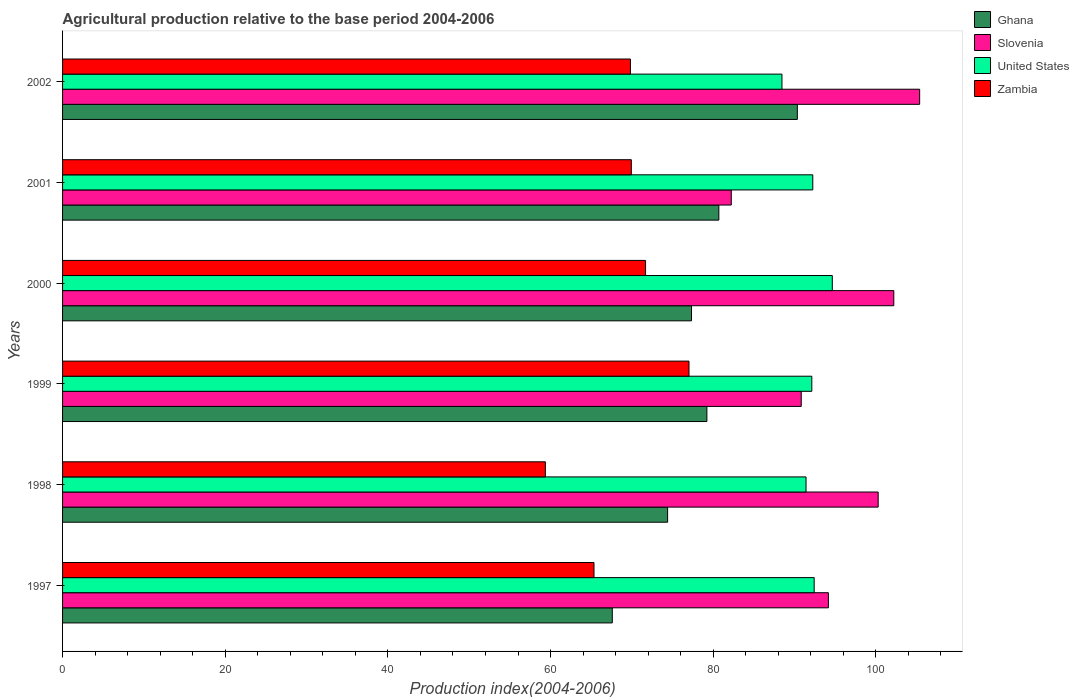How many bars are there on the 3rd tick from the top?
Provide a succinct answer. 4. How many bars are there on the 5th tick from the bottom?
Provide a short and direct response. 4. What is the label of the 2nd group of bars from the top?
Provide a short and direct response. 2001. In how many cases, is the number of bars for a given year not equal to the number of legend labels?
Your response must be concise. 0. What is the agricultural production index in Ghana in 1998?
Your response must be concise. 74.39. Across all years, what is the maximum agricultural production index in Slovenia?
Provide a short and direct response. 105.38. Across all years, what is the minimum agricultural production index in Zambia?
Your response must be concise. 59.36. In which year was the agricultural production index in Ghana maximum?
Your response must be concise. 2002. In which year was the agricultural production index in Zambia minimum?
Provide a short and direct response. 1998. What is the total agricultural production index in Ghana in the graph?
Give a very brief answer. 469.56. What is the difference between the agricultural production index in Zambia in 2000 and that in 2002?
Offer a terse response. 1.86. What is the difference between the agricultural production index in Zambia in 1997 and the agricultural production index in Ghana in 1998?
Keep it short and to the point. -9.05. What is the average agricultural production index in Slovenia per year?
Your answer should be very brief. 95.84. In the year 1999, what is the difference between the agricultural production index in Slovenia and agricultural production index in Zambia?
Give a very brief answer. 13.8. In how many years, is the agricultural production index in Zambia greater than 72 ?
Ensure brevity in your answer.  1. What is the ratio of the agricultural production index in Zambia in 1997 to that in 1998?
Ensure brevity in your answer.  1.1. Is the difference between the agricultural production index in Slovenia in 1997 and 1999 greater than the difference between the agricultural production index in Zambia in 1997 and 1999?
Keep it short and to the point. Yes. What is the difference between the highest and the second highest agricultural production index in United States?
Provide a succinct answer. 2.23. What is the difference between the highest and the lowest agricultural production index in Ghana?
Provide a succinct answer. 22.75. Is it the case that in every year, the sum of the agricultural production index in Ghana and agricultural production index in Slovenia is greater than the sum of agricultural production index in Zambia and agricultural production index in United States?
Offer a terse response. Yes. Is it the case that in every year, the sum of the agricultural production index in Zambia and agricultural production index in Ghana is greater than the agricultural production index in Slovenia?
Provide a short and direct response. Yes. How many bars are there?
Give a very brief answer. 24. Are all the bars in the graph horizontal?
Provide a short and direct response. Yes. Does the graph contain any zero values?
Make the answer very short. No. How many legend labels are there?
Your answer should be compact. 4. How are the legend labels stacked?
Ensure brevity in your answer.  Vertical. What is the title of the graph?
Ensure brevity in your answer.  Agricultural production relative to the base period 2004-2006. What is the label or title of the X-axis?
Offer a very short reply. Production index(2004-2006). What is the label or title of the Y-axis?
Provide a short and direct response. Years. What is the Production index(2004-2006) in Ghana in 1997?
Provide a short and direct response. 67.59. What is the Production index(2004-2006) of Slovenia in 1997?
Keep it short and to the point. 94.16. What is the Production index(2004-2006) of United States in 1997?
Keep it short and to the point. 92.41. What is the Production index(2004-2006) in Zambia in 1997?
Ensure brevity in your answer.  65.34. What is the Production index(2004-2006) of Ghana in 1998?
Ensure brevity in your answer.  74.39. What is the Production index(2004-2006) in Slovenia in 1998?
Offer a very short reply. 100.28. What is the Production index(2004-2006) in United States in 1998?
Keep it short and to the point. 91.41. What is the Production index(2004-2006) of Zambia in 1998?
Provide a short and direct response. 59.36. What is the Production index(2004-2006) of Ghana in 1999?
Ensure brevity in your answer.  79.22. What is the Production index(2004-2006) of Slovenia in 1999?
Make the answer very short. 90.82. What is the Production index(2004-2006) of United States in 1999?
Provide a short and direct response. 92.12. What is the Production index(2004-2006) of Zambia in 1999?
Your answer should be compact. 77.02. What is the Production index(2004-2006) of Ghana in 2000?
Offer a very short reply. 77.33. What is the Production index(2004-2006) of Slovenia in 2000?
Ensure brevity in your answer.  102.2. What is the Production index(2004-2006) of United States in 2000?
Keep it short and to the point. 94.64. What is the Production index(2004-2006) of Zambia in 2000?
Your response must be concise. 71.68. What is the Production index(2004-2006) in Ghana in 2001?
Ensure brevity in your answer.  80.69. What is the Production index(2004-2006) of Slovenia in 2001?
Offer a very short reply. 82.22. What is the Production index(2004-2006) of United States in 2001?
Your answer should be very brief. 92.24. What is the Production index(2004-2006) of Zambia in 2001?
Your answer should be compact. 69.93. What is the Production index(2004-2006) of Ghana in 2002?
Provide a short and direct response. 90.34. What is the Production index(2004-2006) of Slovenia in 2002?
Offer a very short reply. 105.38. What is the Production index(2004-2006) in United States in 2002?
Your answer should be very brief. 88.45. What is the Production index(2004-2006) in Zambia in 2002?
Give a very brief answer. 69.82. Across all years, what is the maximum Production index(2004-2006) of Ghana?
Offer a very short reply. 90.34. Across all years, what is the maximum Production index(2004-2006) in Slovenia?
Make the answer very short. 105.38. Across all years, what is the maximum Production index(2004-2006) in United States?
Your response must be concise. 94.64. Across all years, what is the maximum Production index(2004-2006) of Zambia?
Provide a succinct answer. 77.02. Across all years, what is the minimum Production index(2004-2006) in Ghana?
Give a very brief answer. 67.59. Across all years, what is the minimum Production index(2004-2006) in Slovenia?
Give a very brief answer. 82.22. Across all years, what is the minimum Production index(2004-2006) in United States?
Give a very brief answer. 88.45. Across all years, what is the minimum Production index(2004-2006) in Zambia?
Your response must be concise. 59.36. What is the total Production index(2004-2006) in Ghana in the graph?
Your answer should be compact. 469.56. What is the total Production index(2004-2006) of Slovenia in the graph?
Your answer should be very brief. 575.06. What is the total Production index(2004-2006) in United States in the graph?
Provide a short and direct response. 551.27. What is the total Production index(2004-2006) of Zambia in the graph?
Ensure brevity in your answer.  413.15. What is the difference between the Production index(2004-2006) of Ghana in 1997 and that in 1998?
Offer a very short reply. -6.8. What is the difference between the Production index(2004-2006) in Slovenia in 1997 and that in 1998?
Keep it short and to the point. -6.12. What is the difference between the Production index(2004-2006) of United States in 1997 and that in 1998?
Provide a short and direct response. 1. What is the difference between the Production index(2004-2006) of Zambia in 1997 and that in 1998?
Your answer should be compact. 5.98. What is the difference between the Production index(2004-2006) of Ghana in 1997 and that in 1999?
Keep it short and to the point. -11.63. What is the difference between the Production index(2004-2006) in Slovenia in 1997 and that in 1999?
Offer a terse response. 3.34. What is the difference between the Production index(2004-2006) in United States in 1997 and that in 1999?
Offer a very short reply. 0.29. What is the difference between the Production index(2004-2006) in Zambia in 1997 and that in 1999?
Give a very brief answer. -11.68. What is the difference between the Production index(2004-2006) in Ghana in 1997 and that in 2000?
Ensure brevity in your answer.  -9.74. What is the difference between the Production index(2004-2006) of Slovenia in 1997 and that in 2000?
Offer a terse response. -8.04. What is the difference between the Production index(2004-2006) of United States in 1997 and that in 2000?
Provide a succinct answer. -2.23. What is the difference between the Production index(2004-2006) in Zambia in 1997 and that in 2000?
Offer a very short reply. -6.34. What is the difference between the Production index(2004-2006) in Slovenia in 1997 and that in 2001?
Give a very brief answer. 11.94. What is the difference between the Production index(2004-2006) in United States in 1997 and that in 2001?
Offer a very short reply. 0.17. What is the difference between the Production index(2004-2006) in Zambia in 1997 and that in 2001?
Your answer should be compact. -4.59. What is the difference between the Production index(2004-2006) in Ghana in 1997 and that in 2002?
Provide a succinct answer. -22.75. What is the difference between the Production index(2004-2006) of Slovenia in 1997 and that in 2002?
Make the answer very short. -11.22. What is the difference between the Production index(2004-2006) of United States in 1997 and that in 2002?
Make the answer very short. 3.96. What is the difference between the Production index(2004-2006) of Zambia in 1997 and that in 2002?
Keep it short and to the point. -4.48. What is the difference between the Production index(2004-2006) in Ghana in 1998 and that in 1999?
Make the answer very short. -4.83. What is the difference between the Production index(2004-2006) in Slovenia in 1998 and that in 1999?
Keep it short and to the point. 9.46. What is the difference between the Production index(2004-2006) in United States in 1998 and that in 1999?
Give a very brief answer. -0.71. What is the difference between the Production index(2004-2006) in Zambia in 1998 and that in 1999?
Your response must be concise. -17.66. What is the difference between the Production index(2004-2006) in Ghana in 1998 and that in 2000?
Make the answer very short. -2.94. What is the difference between the Production index(2004-2006) in Slovenia in 1998 and that in 2000?
Provide a succinct answer. -1.92. What is the difference between the Production index(2004-2006) of United States in 1998 and that in 2000?
Your response must be concise. -3.23. What is the difference between the Production index(2004-2006) of Zambia in 1998 and that in 2000?
Keep it short and to the point. -12.32. What is the difference between the Production index(2004-2006) in Slovenia in 1998 and that in 2001?
Your answer should be very brief. 18.06. What is the difference between the Production index(2004-2006) in United States in 1998 and that in 2001?
Provide a short and direct response. -0.83. What is the difference between the Production index(2004-2006) of Zambia in 1998 and that in 2001?
Provide a short and direct response. -10.57. What is the difference between the Production index(2004-2006) of Ghana in 1998 and that in 2002?
Give a very brief answer. -15.95. What is the difference between the Production index(2004-2006) of Slovenia in 1998 and that in 2002?
Offer a very short reply. -5.1. What is the difference between the Production index(2004-2006) of United States in 1998 and that in 2002?
Ensure brevity in your answer.  2.96. What is the difference between the Production index(2004-2006) of Zambia in 1998 and that in 2002?
Offer a very short reply. -10.46. What is the difference between the Production index(2004-2006) in Ghana in 1999 and that in 2000?
Your response must be concise. 1.89. What is the difference between the Production index(2004-2006) of Slovenia in 1999 and that in 2000?
Keep it short and to the point. -11.38. What is the difference between the Production index(2004-2006) in United States in 1999 and that in 2000?
Your answer should be very brief. -2.52. What is the difference between the Production index(2004-2006) of Zambia in 1999 and that in 2000?
Offer a terse response. 5.34. What is the difference between the Production index(2004-2006) in Ghana in 1999 and that in 2001?
Your response must be concise. -1.47. What is the difference between the Production index(2004-2006) in United States in 1999 and that in 2001?
Give a very brief answer. -0.12. What is the difference between the Production index(2004-2006) of Zambia in 1999 and that in 2001?
Give a very brief answer. 7.09. What is the difference between the Production index(2004-2006) in Ghana in 1999 and that in 2002?
Keep it short and to the point. -11.12. What is the difference between the Production index(2004-2006) in Slovenia in 1999 and that in 2002?
Offer a very short reply. -14.56. What is the difference between the Production index(2004-2006) in United States in 1999 and that in 2002?
Provide a short and direct response. 3.67. What is the difference between the Production index(2004-2006) of Ghana in 2000 and that in 2001?
Provide a succinct answer. -3.36. What is the difference between the Production index(2004-2006) in Slovenia in 2000 and that in 2001?
Provide a succinct answer. 19.98. What is the difference between the Production index(2004-2006) of United States in 2000 and that in 2001?
Your response must be concise. 2.4. What is the difference between the Production index(2004-2006) of Zambia in 2000 and that in 2001?
Offer a terse response. 1.75. What is the difference between the Production index(2004-2006) in Ghana in 2000 and that in 2002?
Your answer should be compact. -13.01. What is the difference between the Production index(2004-2006) in Slovenia in 2000 and that in 2002?
Your answer should be compact. -3.18. What is the difference between the Production index(2004-2006) of United States in 2000 and that in 2002?
Give a very brief answer. 6.19. What is the difference between the Production index(2004-2006) of Zambia in 2000 and that in 2002?
Provide a short and direct response. 1.86. What is the difference between the Production index(2004-2006) of Ghana in 2001 and that in 2002?
Ensure brevity in your answer.  -9.65. What is the difference between the Production index(2004-2006) in Slovenia in 2001 and that in 2002?
Your response must be concise. -23.16. What is the difference between the Production index(2004-2006) of United States in 2001 and that in 2002?
Your answer should be very brief. 3.79. What is the difference between the Production index(2004-2006) in Zambia in 2001 and that in 2002?
Provide a succinct answer. 0.11. What is the difference between the Production index(2004-2006) in Ghana in 1997 and the Production index(2004-2006) in Slovenia in 1998?
Your response must be concise. -32.69. What is the difference between the Production index(2004-2006) in Ghana in 1997 and the Production index(2004-2006) in United States in 1998?
Ensure brevity in your answer.  -23.82. What is the difference between the Production index(2004-2006) of Ghana in 1997 and the Production index(2004-2006) of Zambia in 1998?
Offer a very short reply. 8.23. What is the difference between the Production index(2004-2006) in Slovenia in 1997 and the Production index(2004-2006) in United States in 1998?
Your answer should be very brief. 2.75. What is the difference between the Production index(2004-2006) of Slovenia in 1997 and the Production index(2004-2006) of Zambia in 1998?
Keep it short and to the point. 34.8. What is the difference between the Production index(2004-2006) of United States in 1997 and the Production index(2004-2006) of Zambia in 1998?
Provide a short and direct response. 33.05. What is the difference between the Production index(2004-2006) of Ghana in 1997 and the Production index(2004-2006) of Slovenia in 1999?
Provide a short and direct response. -23.23. What is the difference between the Production index(2004-2006) in Ghana in 1997 and the Production index(2004-2006) in United States in 1999?
Keep it short and to the point. -24.53. What is the difference between the Production index(2004-2006) in Ghana in 1997 and the Production index(2004-2006) in Zambia in 1999?
Your answer should be very brief. -9.43. What is the difference between the Production index(2004-2006) of Slovenia in 1997 and the Production index(2004-2006) of United States in 1999?
Your response must be concise. 2.04. What is the difference between the Production index(2004-2006) in Slovenia in 1997 and the Production index(2004-2006) in Zambia in 1999?
Make the answer very short. 17.14. What is the difference between the Production index(2004-2006) in United States in 1997 and the Production index(2004-2006) in Zambia in 1999?
Make the answer very short. 15.39. What is the difference between the Production index(2004-2006) of Ghana in 1997 and the Production index(2004-2006) of Slovenia in 2000?
Your response must be concise. -34.61. What is the difference between the Production index(2004-2006) in Ghana in 1997 and the Production index(2004-2006) in United States in 2000?
Keep it short and to the point. -27.05. What is the difference between the Production index(2004-2006) of Ghana in 1997 and the Production index(2004-2006) of Zambia in 2000?
Provide a short and direct response. -4.09. What is the difference between the Production index(2004-2006) of Slovenia in 1997 and the Production index(2004-2006) of United States in 2000?
Offer a terse response. -0.48. What is the difference between the Production index(2004-2006) of Slovenia in 1997 and the Production index(2004-2006) of Zambia in 2000?
Make the answer very short. 22.48. What is the difference between the Production index(2004-2006) of United States in 1997 and the Production index(2004-2006) of Zambia in 2000?
Give a very brief answer. 20.73. What is the difference between the Production index(2004-2006) of Ghana in 1997 and the Production index(2004-2006) of Slovenia in 2001?
Your response must be concise. -14.63. What is the difference between the Production index(2004-2006) of Ghana in 1997 and the Production index(2004-2006) of United States in 2001?
Ensure brevity in your answer.  -24.65. What is the difference between the Production index(2004-2006) of Ghana in 1997 and the Production index(2004-2006) of Zambia in 2001?
Offer a terse response. -2.34. What is the difference between the Production index(2004-2006) of Slovenia in 1997 and the Production index(2004-2006) of United States in 2001?
Offer a terse response. 1.92. What is the difference between the Production index(2004-2006) of Slovenia in 1997 and the Production index(2004-2006) of Zambia in 2001?
Offer a terse response. 24.23. What is the difference between the Production index(2004-2006) of United States in 1997 and the Production index(2004-2006) of Zambia in 2001?
Ensure brevity in your answer.  22.48. What is the difference between the Production index(2004-2006) of Ghana in 1997 and the Production index(2004-2006) of Slovenia in 2002?
Your response must be concise. -37.79. What is the difference between the Production index(2004-2006) in Ghana in 1997 and the Production index(2004-2006) in United States in 2002?
Your response must be concise. -20.86. What is the difference between the Production index(2004-2006) in Ghana in 1997 and the Production index(2004-2006) in Zambia in 2002?
Give a very brief answer. -2.23. What is the difference between the Production index(2004-2006) in Slovenia in 1997 and the Production index(2004-2006) in United States in 2002?
Keep it short and to the point. 5.71. What is the difference between the Production index(2004-2006) of Slovenia in 1997 and the Production index(2004-2006) of Zambia in 2002?
Provide a short and direct response. 24.34. What is the difference between the Production index(2004-2006) in United States in 1997 and the Production index(2004-2006) in Zambia in 2002?
Make the answer very short. 22.59. What is the difference between the Production index(2004-2006) of Ghana in 1998 and the Production index(2004-2006) of Slovenia in 1999?
Offer a terse response. -16.43. What is the difference between the Production index(2004-2006) of Ghana in 1998 and the Production index(2004-2006) of United States in 1999?
Offer a terse response. -17.73. What is the difference between the Production index(2004-2006) in Ghana in 1998 and the Production index(2004-2006) in Zambia in 1999?
Give a very brief answer. -2.63. What is the difference between the Production index(2004-2006) of Slovenia in 1998 and the Production index(2004-2006) of United States in 1999?
Ensure brevity in your answer.  8.16. What is the difference between the Production index(2004-2006) in Slovenia in 1998 and the Production index(2004-2006) in Zambia in 1999?
Your response must be concise. 23.26. What is the difference between the Production index(2004-2006) of United States in 1998 and the Production index(2004-2006) of Zambia in 1999?
Your answer should be compact. 14.39. What is the difference between the Production index(2004-2006) of Ghana in 1998 and the Production index(2004-2006) of Slovenia in 2000?
Offer a terse response. -27.81. What is the difference between the Production index(2004-2006) in Ghana in 1998 and the Production index(2004-2006) in United States in 2000?
Give a very brief answer. -20.25. What is the difference between the Production index(2004-2006) of Ghana in 1998 and the Production index(2004-2006) of Zambia in 2000?
Offer a very short reply. 2.71. What is the difference between the Production index(2004-2006) in Slovenia in 1998 and the Production index(2004-2006) in United States in 2000?
Your response must be concise. 5.64. What is the difference between the Production index(2004-2006) in Slovenia in 1998 and the Production index(2004-2006) in Zambia in 2000?
Provide a short and direct response. 28.6. What is the difference between the Production index(2004-2006) of United States in 1998 and the Production index(2004-2006) of Zambia in 2000?
Keep it short and to the point. 19.73. What is the difference between the Production index(2004-2006) of Ghana in 1998 and the Production index(2004-2006) of Slovenia in 2001?
Provide a short and direct response. -7.83. What is the difference between the Production index(2004-2006) of Ghana in 1998 and the Production index(2004-2006) of United States in 2001?
Your answer should be compact. -17.85. What is the difference between the Production index(2004-2006) of Ghana in 1998 and the Production index(2004-2006) of Zambia in 2001?
Keep it short and to the point. 4.46. What is the difference between the Production index(2004-2006) in Slovenia in 1998 and the Production index(2004-2006) in United States in 2001?
Keep it short and to the point. 8.04. What is the difference between the Production index(2004-2006) in Slovenia in 1998 and the Production index(2004-2006) in Zambia in 2001?
Give a very brief answer. 30.35. What is the difference between the Production index(2004-2006) in United States in 1998 and the Production index(2004-2006) in Zambia in 2001?
Offer a terse response. 21.48. What is the difference between the Production index(2004-2006) in Ghana in 1998 and the Production index(2004-2006) in Slovenia in 2002?
Offer a very short reply. -30.99. What is the difference between the Production index(2004-2006) of Ghana in 1998 and the Production index(2004-2006) of United States in 2002?
Make the answer very short. -14.06. What is the difference between the Production index(2004-2006) in Ghana in 1998 and the Production index(2004-2006) in Zambia in 2002?
Keep it short and to the point. 4.57. What is the difference between the Production index(2004-2006) in Slovenia in 1998 and the Production index(2004-2006) in United States in 2002?
Keep it short and to the point. 11.83. What is the difference between the Production index(2004-2006) of Slovenia in 1998 and the Production index(2004-2006) of Zambia in 2002?
Give a very brief answer. 30.46. What is the difference between the Production index(2004-2006) in United States in 1998 and the Production index(2004-2006) in Zambia in 2002?
Provide a short and direct response. 21.59. What is the difference between the Production index(2004-2006) of Ghana in 1999 and the Production index(2004-2006) of Slovenia in 2000?
Offer a terse response. -22.98. What is the difference between the Production index(2004-2006) of Ghana in 1999 and the Production index(2004-2006) of United States in 2000?
Offer a very short reply. -15.42. What is the difference between the Production index(2004-2006) of Ghana in 1999 and the Production index(2004-2006) of Zambia in 2000?
Provide a short and direct response. 7.54. What is the difference between the Production index(2004-2006) in Slovenia in 1999 and the Production index(2004-2006) in United States in 2000?
Provide a short and direct response. -3.82. What is the difference between the Production index(2004-2006) in Slovenia in 1999 and the Production index(2004-2006) in Zambia in 2000?
Keep it short and to the point. 19.14. What is the difference between the Production index(2004-2006) in United States in 1999 and the Production index(2004-2006) in Zambia in 2000?
Keep it short and to the point. 20.44. What is the difference between the Production index(2004-2006) in Ghana in 1999 and the Production index(2004-2006) in United States in 2001?
Your response must be concise. -13.02. What is the difference between the Production index(2004-2006) of Ghana in 1999 and the Production index(2004-2006) of Zambia in 2001?
Give a very brief answer. 9.29. What is the difference between the Production index(2004-2006) of Slovenia in 1999 and the Production index(2004-2006) of United States in 2001?
Provide a short and direct response. -1.42. What is the difference between the Production index(2004-2006) in Slovenia in 1999 and the Production index(2004-2006) in Zambia in 2001?
Offer a terse response. 20.89. What is the difference between the Production index(2004-2006) in United States in 1999 and the Production index(2004-2006) in Zambia in 2001?
Keep it short and to the point. 22.19. What is the difference between the Production index(2004-2006) in Ghana in 1999 and the Production index(2004-2006) in Slovenia in 2002?
Your answer should be very brief. -26.16. What is the difference between the Production index(2004-2006) of Ghana in 1999 and the Production index(2004-2006) of United States in 2002?
Give a very brief answer. -9.23. What is the difference between the Production index(2004-2006) in Ghana in 1999 and the Production index(2004-2006) in Zambia in 2002?
Your answer should be compact. 9.4. What is the difference between the Production index(2004-2006) in Slovenia in 1999 and the Production index(2004-2006) in United States in 2002?
Your response must be concise. 2.37. What is the difference between the Production index(2004-2006) of Slovenia in 1999 and the Production index(2004-2006) of Zambia in 2002?
Your answer should be very brief. 21. What is the difference between the Production index(2004-2006) of United States in 1999 and the Production index(2004-2006) of Zambia in 2002?
Keep it short and to the point. 22.3. What is the difference between the Production index(2004-2006) of Ghana in 2000 and the Production index(2004-2006) of Slovenia in 2001?
Your answer should be compact. -4.89. What is the difference between the Production index(2004-2006) in Ghana in 2000 and the Production index(2004-2006) in United States in 2001?
Offer a terse response. -14.91. What is the difference between the Production index(2004-2006) of Ghana in 2000 and the Production index(2004-2006) of Zambia in 2001?
Make the answer very short. 7.4. What is the difference between the Production index(2004-2006) of Slovenia in 2000 and the Production index(2004-2006) of United States in 2001?
Your answer should be compact. 9.96. What is the difference between the Production index(2004-2006) of Slovenia in 2000 and the Production index(2004-2006) of Zambia in 2001?
Ensure brevity in your answer.  32.27. What is the difference between the Production index(2004-2006) of United States in 2000 and the Production index(2004-2006) of Zambia in 2001?
Provide a short and direct response. 24.71. What is the difference between the Production index(2004-2006) in Ghana in 2000 and the Production index(2004-2006) in Slovenia in 2002?
Keep it short and to the point. -28.05. What is the difference between the Production index(2004-2006) of Ghana in 2000 and the Production index(2004-2006) of United States in 2002?
Provide a short and direct response. -11.12. What is the difference between the Production index(2004-2006) of Ghana in 2000 and the Production index(2004-2006) of Zambia in 2002?
Ensure brevity in your answer.  7.51. What is the difference between the Production index(2004-2006) of Slovenia in 2000 and the Production index(2004-2006) of United States in 2002?
Offer a very short reply. 13.75. What is the difference between the Production index(2004-2006) of Slovenia in 2000 and the Production index(2004-2006) of Zambia in 2002?
Your response must be concise. 32.38. What is the difference between the Production index(2004-2006) in United States in 2000 and the Production index(2004-2006) in Zambia in 2002?
Your answer should be compact. 24.82. What is the difference between the Production index(2004-2006) in Ghana in 2001 and the Production index(2004-2006) in Slovenia in 2002?
Keep it short and to the point. -24.69. What is the difference between the Production index(2004-2006) of Ghana in 2001 and the Production index(2004-2006) of United States in 2002?
Offer a terse response. -7.76. What is the difference between the Production index(2004-2006) in Ghana in 2001 and the Production index(2004-2006) in Zambia in 2002?
Your answer should be very brief. 10.87. What is the difference between the Production index(2004-2006) in Slovenia in 2001 and the Production index(2004-2006) in United States in 2002?
Offer a terse response. -6.23. What is the difference between the Production index(2004-2006) in United States in 2001 and the Production index(2004-2006) in Zambia in 2002?
Give a very brief answer. 22.42. What is the average Production index(2004-2006) of Ghana per year?
Make the answer very short. 78.26. What is the average Production index(2004-2006) of Slovenia per year?
Your answer should be very brief. 95.84. What is the average Production index(2004-2006) of United States per year?
Ensure brevity in your answer.  91.88. What is the average Production index(2004-2006) in Zambia per year?
Make the answer very short. 68.86. In the year 1997, what is the difference between the Production index(2004-2006) in Ghana and Production index(2004-2006) in Slovenia?
Your answer should be very brief. -26.57. In the year 1997, what is the difference between the Production index(2004-2006) in Ghana and Production index(2004-2006) in United States?
Your answer should be very brief. -24.82. In the year 1997, what is the difference between the Production index(2004-2006) of Ghana and Production index(2004-2006) of Zambia?
Your answer should be very brief. 2.25. In the year 1997, what is the difference between the Production index(2004-2006) of Slovenia and Production index(2004-2006) of United States?
Offer a very short reply. 1.75. In the year 1997, what is the difference between the Production index(2004-2006) in Slovenia and Production index(2004-2006) in Zambia?
Provide a short and direct response. 28.82. In the year 1997, what is the difference between the Production index(2004-2006) in United States and Production index(2004-2006) in Zambia?
Ensure brevity in your answer.  27.07. In the year 1998, what is the difference between the Production index(2004-2006) of Ghana and Production index(2004-2006) of Slovenia?
Keep it short and to the point. -25.89. In the year 1998, what is the difference between the Production index(2004-2006) of Ghana and Production index(2004-2006) of United States?
Provide a short and direct response. -17.02. In the year 1998, what is the difference between the Production index(2004-2006) in Ghana and Production index(2004-2006) in Zambia?
Give a very brief answer. 15.03. In the year 1998, what is the difference between the Production index(2004-2006) of Slovenia and Production index(2004-2006) of United States?
Provide a short and direct response. 8.87. In the year 1998, what is the difference between the Production index(2004-2006) in Slovenia and Production index(2004-2006) in Zambia?
Your answer should be compact. 40.92. In the year 1998, what is the difference between the Production index(2004-2006) of United States and Production index(2004-2006) of Zambia?
Offer a very short reply. 32.05. In the year 1999, what is the difference between the Production index(2004-2006) of Ghana and Production index(2004-2006) of Slovenia?
Your response must be concise. -11.6. In the year 1999, what is the difference between the Production index(2004-2006) of Ghana and Production index(2004-2006) of United States?
Provide a short and direct response. -12.9. In the year 1999, what is the difference between the Production index(2004-2006) of Ghana and Production index(2004-2006) of Zambia?
Keep it short and to the point. 2.2. In the year 1999, what is the difference between the Production index(2004-2006) in Slovenia and Production index(2004-2006) in United States?
Keep it short and to the point. -1.3. In the year 2000, what is the difference between the Production index(2004-2006) of Ghana and Production index(2004-2006) of Slovenia?
Your answer should be compact. -24.87. In the year 2000, what is the difference between the Production index(2004-2006) of Ghana and Production index(2004-2006) of United States?
Offer a very short reply. -17.31. In the year 2000, what is the difference between the Production index(2004-2006) in Ghana and Production index(2004-2006) in Zambia?
Your answer should be compact. 5.65. In the year 2000, what is the difference between the Production index(2004-2006) in Slovenia and Production index(2004-2006) in United States?
Make the answer very short. 7.56. In the year 2000, what is the difference between the Production index(2004-2006) in Slovenia and Production index(2004-2006) in Zambia?
Keep it short and to the point. 30.52. In the year 2000, what is the difference between the Production index(2004-2006) in United States and Production index(2004-2006) in Zambia?
Keep it short and to the point. 22.96. In the year 2001, what is the difference between the Production index(2004-2006) of Ghana and Production index(2004-2006) of Slovenia?
Your response must be concise. -1.53. In the year 2001, what is the difference between the Production index(2004-2006) of Ghana and Production index(2004-2006) of United States?
Provide a succinct answer. -11.55. In the year 2001, what is the difference between the Production index(2004-2006) in Ghana and Production index(2004-2006) in Zambia?
Make the answer very short. 10.76. In the year 2001, what is the difference between the Production index(2004-2006) of Slovenia and Production index(2004-2006) of United States?
Your response must be concise. -10.02. In the year 2001, what is the difference between the Production index(2004-2006) in Slovenia and Production index(2004-2006) in Zambia?
Provide a succinct answer. 12.29. In the year 2001, what is the difference between the Production index(2004-2006) in United States and Production index(2004-2006) in Zambia?
Keep it short and to the point. 22.31. In the year 2002, what is the difference between the Production index(2004-2006) in Ghana and Production index(2004-2006) in Slovenia?
Offer a very short reply. -15.04. In the year 2002, what is the difference between the Production index(2004-2006) in Ghana and Production index(2004-2006) in United States?
Provide a succinct answer. 1.89. In the year 2002, what is the difference between the Production index(2004-2006) in Ghana and Production index(2004-2006) in Zambia?
Provide a succinct answer. 20.52. In the year 2002, what is the difference between the Production index(2004-2006) in Slovenia and Production index(2004-2006) in United States?
Make the answer very short. 16.93. In the year 2002, what is the difference between the Production index(2004-2006) in Slovenia and Production index(2004-2006) in Zambia?
Provide a succinct answer. 35.56. In the year 2002, what is the difference between the Production index(2004-2006) of United States and Production index(2004-2006) of Zambia?
Keep it short and to the point. 18.63. What is the ratio of the Production index(2004-2006) of Ghana in 1997 to that in 1998?
Offer a terse response. 0.91. What is the ratio of the Production index(2004-2006) in Slovenia in 1997 to that in 1998?
Ensure brevity in your answer.  0.94. What is the ratio of the Production index(2004-2006) in United States in 1997 to that in 1998?
Provide a short and direct response. 1.01. What is the ratio of the Production index(2004-2006) in Zambia in 1997 to that in 1998?
Provide a short and direct response. 1.1. What is the ratio of the Production index(2004-2006) in Ghana in 1997 to that in 1999?
Provide a succinct answer. 0.85. What is the ratio of the Production index(2004-2006) in Slovenia in 1997 to that in 1999?
Your response must be concise. 1.04. What is the ratio of the Production index(2004-2006) in Zambia in 1997 to that in 1999?
Offer a terse response. 0.85. What is the ratio of the Production index(2004-2006) in Ghana in 1997 to that in 2000?
Ensure brevity in your answer.  0.87. What is the ratio of the Production index(2004-2006) of Slovenia in 1997 to that in 2000?
Your answer should be compact. 0.92. What is the ratio of the Production index(2004-2006) in United States in 1997 to that in 2000?
Offer a very short reply. 0.98. What is the ratio of the Production index(2004-2006) in Zambia in 1997 to that in 2000?
Offer a terse response. 0.91. What is the ratio of the Production index(2004-2006) of Ghana in 1997 to that in 2001?
Offer a terse response. 0.84. What is the ratio of the Production index(2004-2006) in Slovenia in 1997 to that in 2001?
Ensure brevity in your answer.  1.15. What is the ratio of the Production index(2004-2006) of Zambia in 1997 to that in 2001?
Offer a terse response. 0.93. What is the ratio of the Production index(2004-2006) of Ghana in 1997 to that in 2002?
Keep it short and to the point. 0.75. What is the ratio of the Production index(2004-2006) in Slovenia in 1997 to that in 2002?
Offer a terse response. 0.89. What is the ratio of the Production index(2004-2006) in United States in 1997 to that in 2002?
Provide a succinct answer. 1.04. What is the ratio of the Production index(2004-2006) in Zambia in 1997 to that in 2002?
Give a very brief answer. 0.94. What is the ratio of the Production index(2004-2006) of Ghana in 1998 to that in 1999?
Ensure brevity in your answer.  0.94. What is the ratio of the Production index(2004-2006) of Slovenia in 1998 to that in 1999?
Give a very brief answer. 1.1. What is the ratio of the Production index(2004-2006) of United States in 1998 to that in 1999?
Your answer should be very brief. 0.99. What is the ratio of the Production index(2004-2006) of Zambia in 1998 to that in 1999?
Make the answer very short. 0.77. What is the ratio of the Production index(2004-2006) in Ghana in 1998 to that in 2000?
Your response must be concise. 0.96. What is the ratio of the Production index(2004-2006) of Slovenia in 1998 to that in 2000?
Provide a short and direct response. 0.98. What is the ratio of the Production index(2004-2006) in United States in 1998 to that in 2000?
Your response must be concise. 0.97. What is the ratio of the Production index(2004-2006) of Zambia in 1998 to that in 2000?
Make the answer very short. 0.83. What is the ratio of the Production index(2004-2006) of Ghana in 1998 to that in 2001?
Offer a very short reply. 0.92. What is the ratio of the Production index(2004-2006) in Slovenia in 1998 to that in 2001?
Make the answer very short. 1.22. What is the ratio of the Production index(2004-2006) of United States in 1998 to that in 2001?
Provide a succinct answer. 0.99. What is the ratio of the Production index(2004-2006) of Zambia in 1998 to that in 2001?
Offer a very short reply. 0.85. What is the ratio of the Production index(2004-2006) in Ghana in 1998 to that in 2002?
Provide a succinct answer. 0.82. What is the ratio of the Production index(2004-2006) of Slovenia in 1998 to that in 2002?
Ensure brevity in your answer.  0.95. What is the ratio of the Production index(2004-2006) of United States in 1998 to that in 2002?
Your response must be concise. 1.03. What is the ratio of the Production index(2004-2006) of Zambia in 1998 to that in 2002?
Offer a terse response. 0.85. What is the ratio of the Production index(2004-2006) in Ghana in 1999 to that in 2000?
Make the answer very short. 1.02. What is the ratio of the Production index(2004-2006) in Slovenia in 1999 to that in 2000?
Your response must be concise. 0.89. What is the ratio of the Production index(2004-2006) in United States in 1999 to that in 2000?
Provide a succinct answer. 0.97. What is the ratio of the Production index(2004-2006) in Zambia in 1999 to that in 2000?
Keep it short and to the point. 1.07. What is the ratio of the Production index(2004-2006) in Ghana in 1999 to that in 2001?
Your answer should be very brief. 0.98. What is the ratio of the Production index(2004-2006) in Slovenia in 1999 to that in 2001?
Keep it short and to the point. 1.1. What is the ratio of the Production index(2004-2006) in United States in 1999 to that in 2001?
Ensure brevity in your answer.  1. What is the ratio of the Production index(2004-2006) of Zambia in 1999 to that in 2001?
Your response must be concise. 1.1. What is the ratio of the Production index(2004-2006) of Ghana in 1999 to that in 2002?
Give a very brief answer. 0.88. What is the ratio of the Production index(2004-2006) of Slovenia in 1999 to that in 2002?
Give a very brief answer. 0.86. What is the ratio of the Production index(2004-2006) in United States in 1999 to that in 2002?
Your answer should be compact. 1.04. What is the ratio of the Production index(2004-2006) in Zambia in 1999 to that in 2002?
Your response must be concise. 1.1. What is the ratio of the Production index(2004-2006) in Ghana in 2000 to that in 2001?
Give a very brief answer. 0.96. What is the ratio of the Production index(2004-2006) in Slovenia in 2000 to that in 2001?
Ensure brevity in your answer.  1.24. What is the ratio of the Production index(2004-2006) in United States in 2000 to that in 2001?
Your answer should be very brief. 1.03. What is the ratio of the Production index(2004-2006) in Ghana in 2000 to that in 2002?
Your response must be concise. 0.86. What is the ratio of the Production index(2004-2006) in Slovenia in 2000 to that in 2002?
Your answer should be compact. 0.97. What is the ratio of the Production index(2004-2006) of United States in 2000 to that in 2002?
Offer a very short reply. 1.07. What is the ratio of the Production index(2004-2006) of Zambia in 2000 to that in 2002?
Keep it short and to the point. 1.03. What is the ratio of the Production index(2004-2006) of Ghana in 2001 to that in 2002?
Give a very brief answer. 0.89. What is the ratio of the Production index(2004-2006) of Slovenia in 2001 to that in 2002?
Offer a terse response. 0.78. What is the ratio of the Production index(2004-2006) in United States in 2001 to that in 2002?
Offer a very short reply. 1.04. What is the difference between the highest and the second highest Production index(2004-2006) of Ghana?
Keep it short and to the point. 9.65. What is the difference between the highest and the second highest Production index(2004-2006) in Slovenia?
Keep it short and to the point. 3.18. What is the difference between the highest and the second highest Production index(2004-2006) of United States?
Offer a terse response. 2.23. What is the difference between the highest and the second highest Production index(2004-2006) in Zambia?
Ensure brevity in your answer.  5.34. What is the difference between the highest and the lowest Production index(2004-2006) of Ghana?
Keep it short and to the point. 22.75. What is the difference between the highest and the lowest Production index(2004-2006) in Slovenia?
Offer a very short reply. 23.16. What is the difference between the highest and the lowest Production index(2004-2006) in United States?
Your answer should be compact. 6.19. What is the difference between the highest and the lowest Production index(2004-2006) of Zambia?
Give a very brief answer. 17.66. 